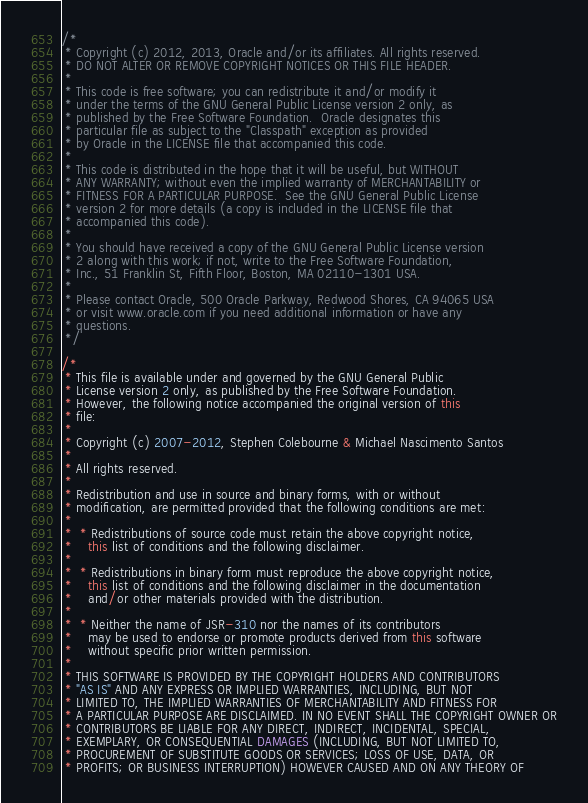<code> <loc_0><loc_0><loc_500><loc_500><_Java_>/*
 * Copyright (c) 2012, 2013, Oracle and/or its affiliates. All rights reserved.
 * DO NOT ALTER OR REMOVE COPYRIGHT NOTICES OR THIS FILE HEADER.
 *
 * This code is free software; you can redistribute it and/or modify it
 * under the terms of the GNU General Public License version 2 only, as
 * published by the Free Software Foundation.  Oracle designates this
 * particular file as subject to the "Classpath" exception as provided
 * by Oracle in the LICENSE file that accompanied this code.
 *
 * This code is distributed in the hope that it will be useful, but WITHOUT
 * ANY WARRANTY; without even the implied warranty of MERCHANTABILITY or
 * FITNESS FOR A PARTICULAR PURPOSE.  See the GNU General Public License
 * version 2 for more details (a copy is included in the LICENSE file that
 * accompanied this code).
 *
 * You should have received a copy of the GNU General Public License version
 * 2 along with this work; if not, write to the Free Software Foundation,
 * Inc., 51 Franklin St, Fifth Floor, Boston, MA 02110-1301 USA.
 *
 * Please contact Oracle, 500 Oracle Parkway, Redwood Shores, CA 94065 USA
 * or visit www.oracle.com if you need additional information or have any
 * questions.
 */

/*
 * This file is available under and governed by the GNU General Public
 * License version 2 only, as published by the Free Software Foundation.
 * However, the following notice accompanied the original version of this
 * file:
 *
 * Copyright (c) 2007-2012, Stephen Colebourne & Michael Nascimento Santos
 *
 * All rights reserved.
 *
 * Redistribution and use in source and binary forms, with or without
 * modification, are permitted provided that the following conditions are met:
 *
 *  * Redistributions of source code must retain the above copyright notice,
 *    this list of conditions and the following disclaimer.
 *
 *  * Redistributions in binary form must reproduce the above copyright notice,
 *    this list of conditions and the following disclaimer in the documentation
 *    and/or other materials provided with the distribution.
 *
 *  * Neither the name of JSR-310 nor the names of its contributors
 *    may be used to endorse or promote products derived from this software
 *    without specific prior written permission.
 *
 * THIS SOFTWARE IS PROVIDED BY THE COPYRIGHT HOLDERS AND CONTRIBUTORS
 * "AS IS" AND ANY EXPRESS OR IMPLIED WARRANTIES, INCLUDING, BUT NOT
 * LIMITED TO, THE IMPLIED WARRANTIES OF MERCHANTABILITY AND FITNESS FOR
 * A PARTICULAR PURPOSE ARE DISCLAIMED. IN NO EVENT SHALL THE COPYRIGHT OWNER OR
 * CONTRIBUTORS BE LIABLE FOR ANY DIRECT, INDIRECT, INCIDENTAL, SPECIAL,
 * EXEMPLARY, OR CONSEQUENTIAL DAMAGES (INCLUDING, BUT NOT LIMITED TO,
 * PROCUREMENT OF SUBSTITUTE GOODS OR SERVICES; LOSS OF USE, DATA, OR
 * PROFITS; OR BUSINESS INTERRUPTION) HOWEVER CAUSED AND ON ANY THEORY OF</code> 